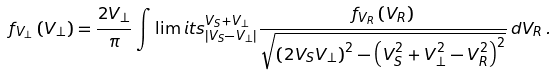<formula> <loc_0><loc_0><loc_500><loc_500>f _ { V _ { \perp } } \left ( V _ { \perp } \right ) = \frac { 2 V _ { \perp } } { \pi } \int \lim i t s _ { \left | V _ { S } - V _ { \perp } \right | } ^ { V _ { S } + V _ { \perp } } \frac { f _ { V _ { R } } \left ( V _ { R } \right ) } { \sqrt { \left ( 2 V _ { S } V _ { \perp } \right ) ^ { 2 } - \left ( V _ { S } ^ { 2 } + V _ { \perp } ^ { 2 } - V _ { R } ^ { 2 } \right ) ^ { 2 } } } \, d V _ { R } \, .</formula> 